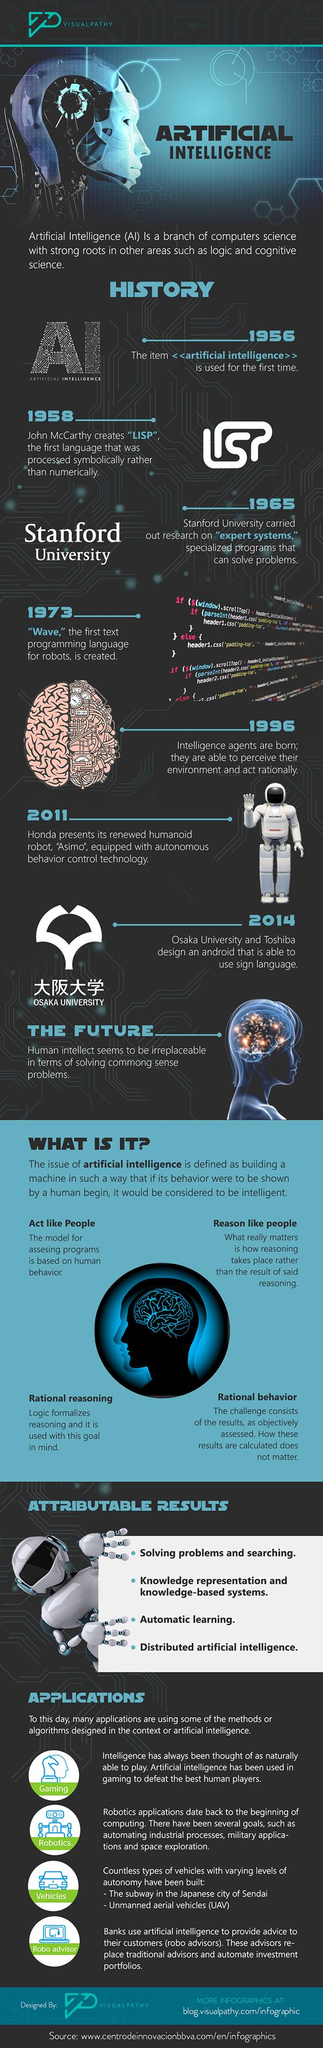Outline some significant characteristics in this image. The third application of AI is the use of vehicles. Artificial intelligence is the second application of AI, primarily used in robotics. The number of factors that determine the intelligence of AI is four. There are four mentions of AI in this infographic. 